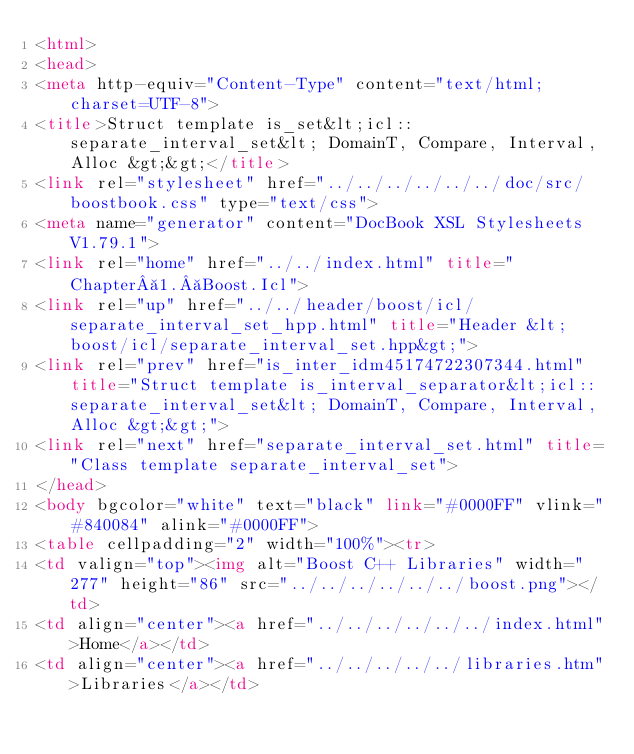<code> <loc_0><loc_0><loc_500><loc_500><_HTML_><html>
<head>
<meta http-equiv="Content-Type" content="text/html; charset=UTF-8">
<title>Struct template is_set&lt;icl::separate_interval_set&lt; DomainT, Compare, Interval, Alloc &gt;&gt;</title>
<link rel="stylesheet" href="../../../../../../doc/src/boostbook.css" type="text/css">
<meta name="generator" content="DocBook XSL Stylesheets V1.79.1">
<link rel="home" href="../../index.html" title="Chapter 1. Boost.Icl">
<link rel="up" href="../../header/boost/icl/separate_interval_set_hpp.html" title="Header &lt;boost/icl/separate_interval_set.hpp&gt;">
<link rel="prev" href="is_inter_idm45174722307344.html" title="Struct template is_interval_separator&lt;icl::separate_interval_set&lt; DomainT, Compare, Interval, Alloc &gt;&gt;">
<link rel="next" href="separate_interval_set.html" title="Class template separate_interval_set">
</head>
<body bgcolor="white" text="black" link="#0000FF" vlink="#840084" alink="#0000FF">
<table cellpadding="2" width="100%"><tr>
<td valign="top"><img alt="Boost C++ Libraries" width="277" height="86" src="../../../../../../boost.png"></td>
<td align="center"><a href="../../../../../../index.html">Home</a></td>
<td align="center"><a href="../../../../../libraries.htm">Libraries</a></td></code> 